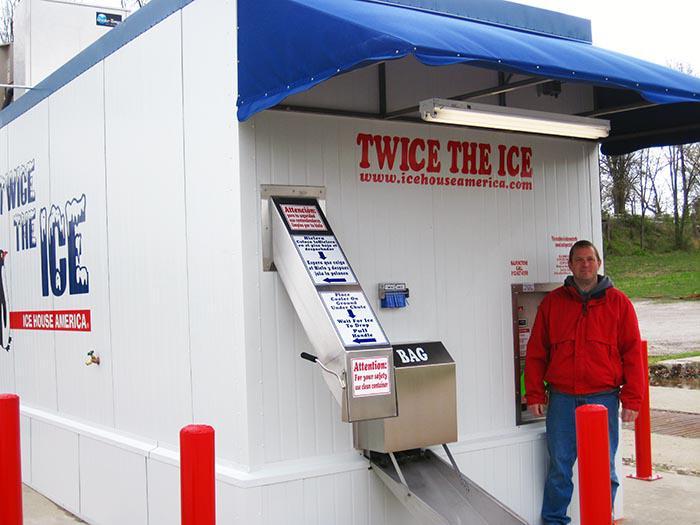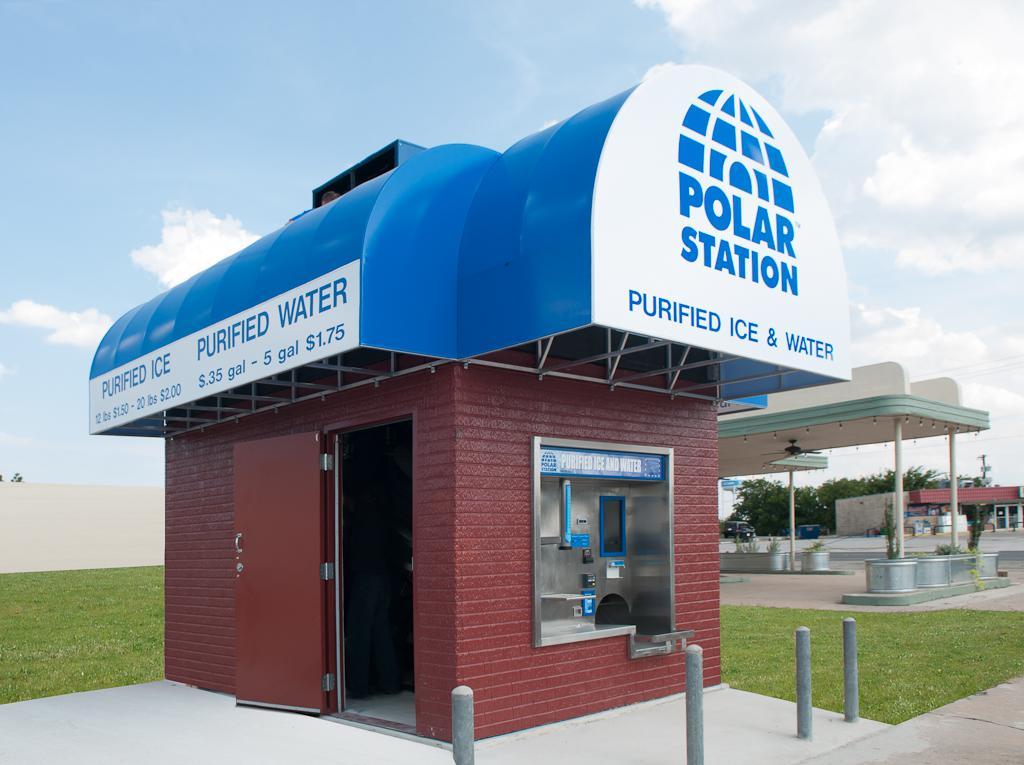The first image is the image on the left, the second image is the image on the right. Evaluate the accuracy of this statement regarding the images: "There are at least two painted penguins on the side of a ice house with blue trim.". Is it true? Answer yes or no. No. The first image is the image on the left, the second image is the image on the right. Examine the images to the left and right. Is the description "A person is standing in front of one of the ice machines." accurate? Answer yes or no. Yes. 